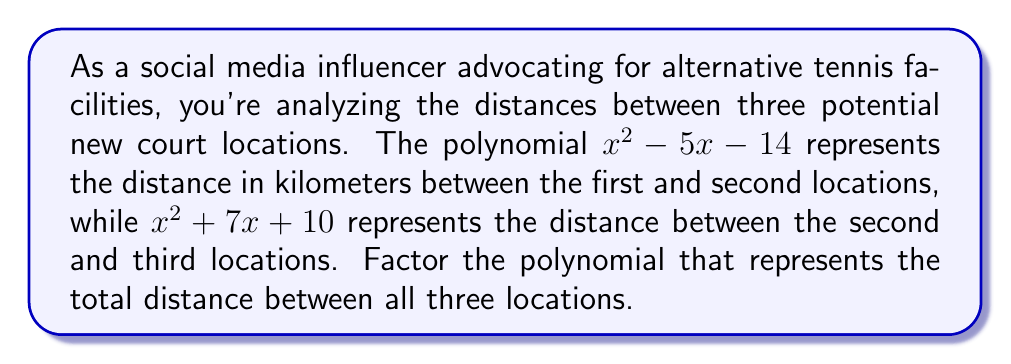Solve this math problem. Let's approach this step-by-step:

1) First, we need to add the two given polynomials to get the total distance:
   $(x^2 - 5x - 14) + (x^2 + 7x + 10)$

2) Combining like terms:
   $x^2 - 5x - 14 + x^2 + 7x + 10$
   $= 2x^2 + 2x - 4$

3) Now we need to factor this polynomial. Let's use the ac-method:
   a = 2, b = 2, c = -4
   
4) We need to find two numbers that multiply to give ac = 2 * (-4) = -8 and add up to b = 2
   Those numbers are 4 and -2

5) Rewrite the middle term using these numbers:
   $2x^2 + 4x - 2x - 4$

6) Group the terms:
   $(2x^2 + 4x) + (-2x - 4)$

7) Factor out the common factors from each group:
   $2x(x + 2) - 2(x + 2)$

8) Factor out the common binomial:
   $(2x - 2)(x + 2)$

9) Simplify:
   $2(x - 1)(x + 2)$

Therefore, the factored polynomial is $2(x - 1)(x + 2)$.
Answer: $2(x - 1)(x + 2)$ 